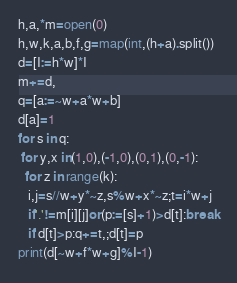Convert code to text. <code><loc_0><loc_0><loc_500><loc_500><_Python_>h,a,*m=open(0)
h,w,k,a,b,f,g=map(int,(h+a).split())
d=[I:=h*w]*I
m+=d,
q=[a:=~w+a*w+b]
d[a]=1
for s in q:
 for y,x in(1,0),(-1,0),(0,1),(0,-1):
  for z in range(k):
   i,j=s//w+y*~z,s%w+x*~z;t=i*w+j
   if'.'!=m[i][j]or(p:=[s]+1)>d[t]:break
   if d[t]>p:q+=t,;d[t]=p
print(d[~w+f*w+g]%I-1)</code> 